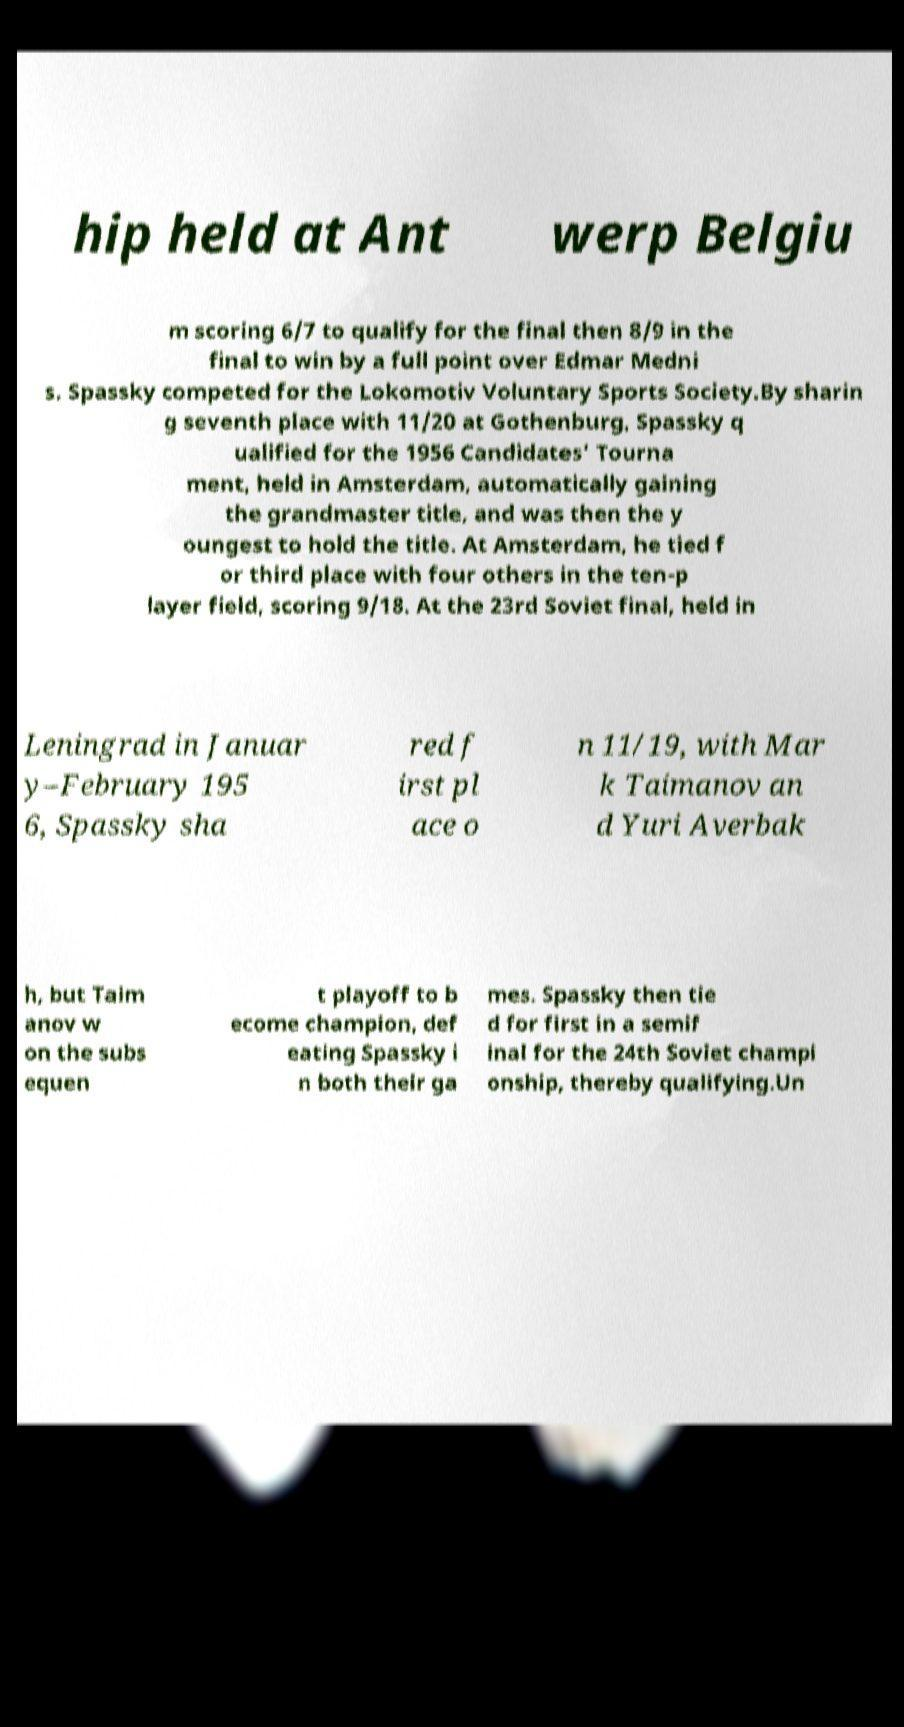There's text embedded in this image that I need extracted. Can you transcribe it verbatim? hip held at Ant werp Belgiu m scoring 6/7 to qualify for the final then 8/9 in the final to win by a full point over Edmar Medni s. Spassky competed for the Lokomotiv Voluntary Sports Society.By sharin g seventh place with 11/20 at Gothenburg, Spassky q ualified for the 1956 Candidates' Tourna ment, held in Amsterdam, automatically gaining the grandmaster title, and was then the y oungest to hold the title. At Amsterdam, he tied f or third place with four others in the ten-p layer field, scoring 9/18. At the 23rd Soviet final, held in Leningrad in Januar y–February 195 6, Spassky sha red f irst pl ace o n 11/19, with Mar k Taimanov an d Yuri Averbak h, but Taim anov w on the subs equen t playoff to b ecome champion, def eating Spassky i n both their ga mes. Spassky then tie d for first in a semif inal for the 24th Soviet champi onship, thereby qualifying.Un 